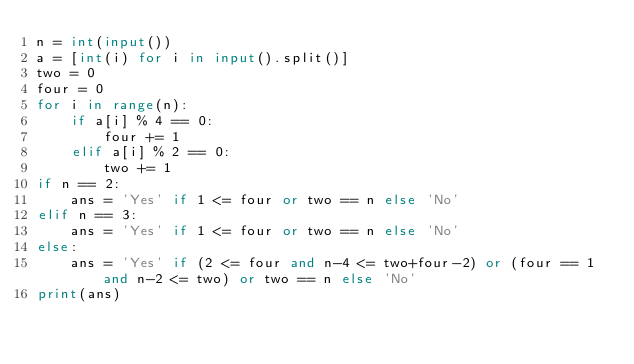<code> <loc_0><loc_0><loc_500><loc_500><_Python_>n = int(input())
a = [int(i) for i in input().split()]
two = 0
four = 0
for i in range(n):
    if a[i] % 4 == 0:
        four += 1
    elif a[i] % 2 == 0:
        two += 1
if n == 2:
    ans = 'Yes' if 1 <= four or two == n else 'No'
elif n == 3:
    ans = 'Yes' if 1 <= four or two == n else 'No'
else:
    ans = 'Yes' if (2 <= four and n-4 <= two+four-2) or (four == 1 and n-2 <= two) or two == n else 'No'
print(ans)</code> 